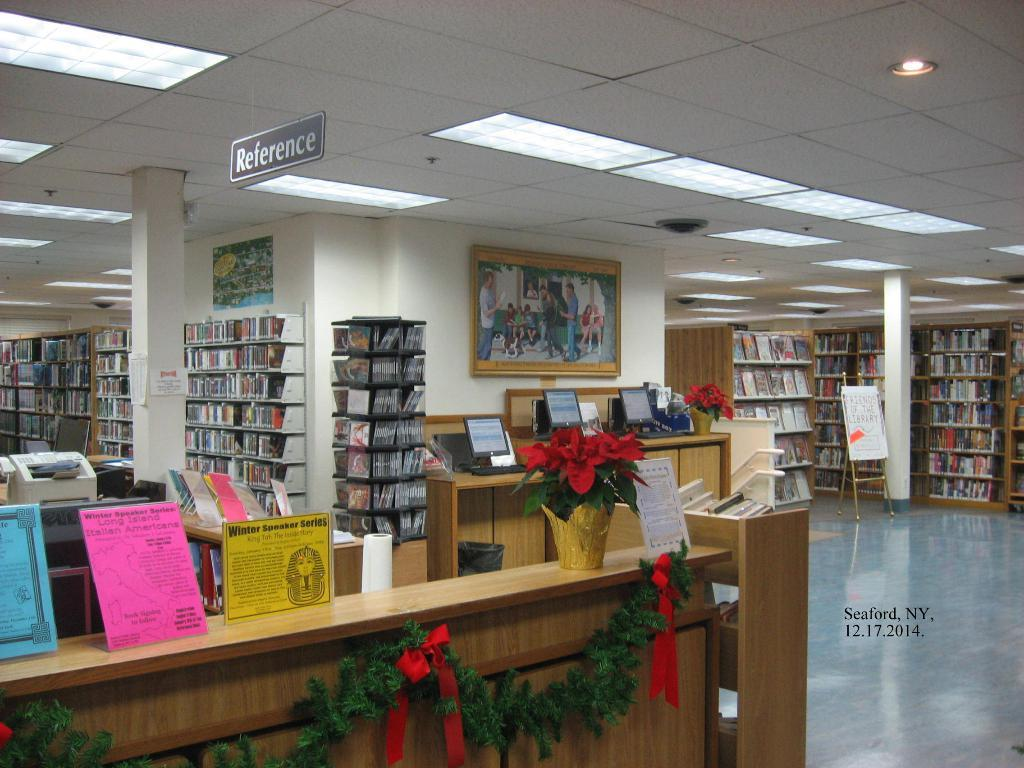<image>
Share a concise interpretation of the image provided. Library with Christmas decorations that has bookshelves filled with books and information. 